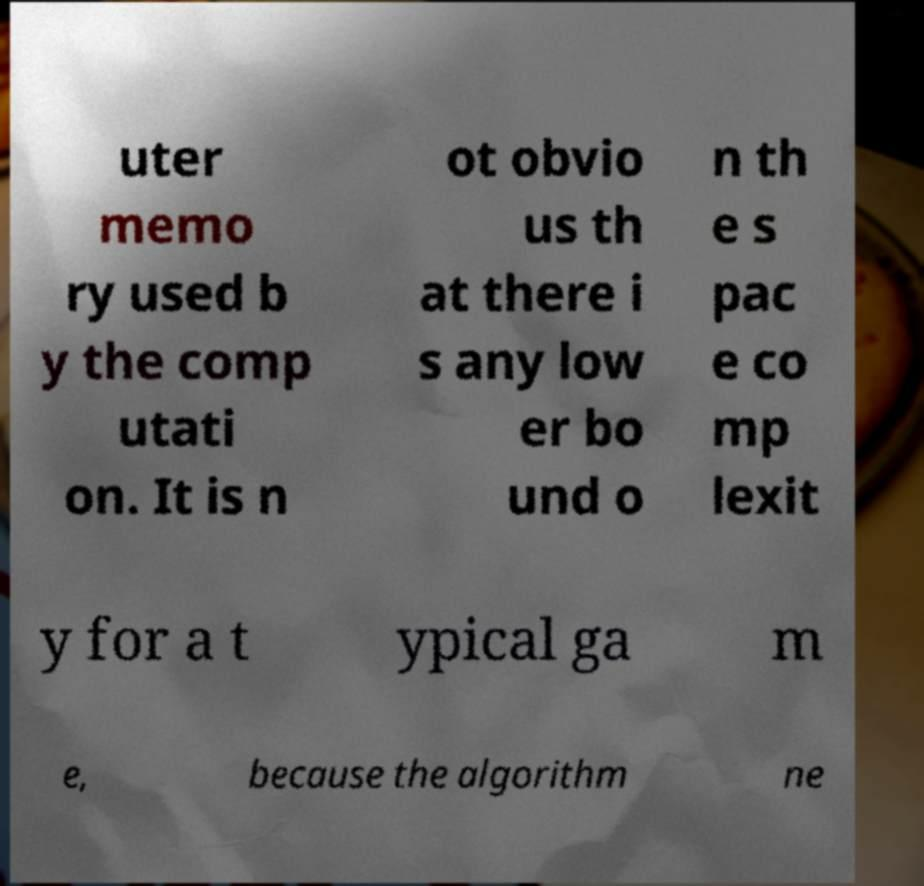Could you extract and type out the text from this image? uter memo ry used b y the comp utati on. It is n ot obvio us th at there i s any low er bo und o n th e s pac e co mp lexit y for a t ypical ga m e, because the algorithm ne 